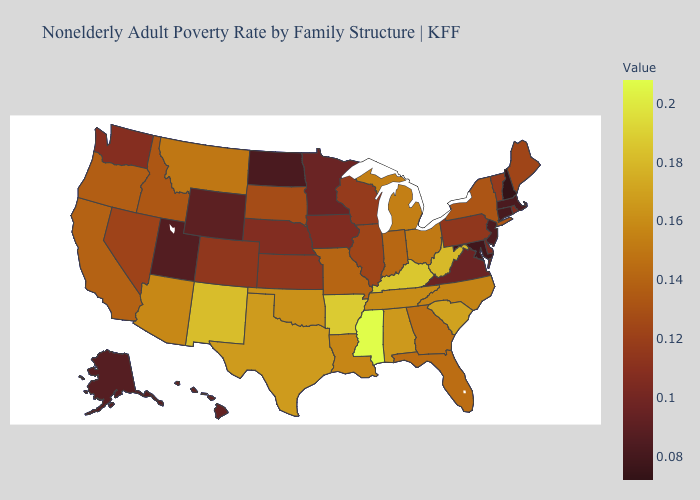Is the legend a continuous bar?
Concise answer only. Yes. Is the legend a continuous bar?
Quick response, please. Yes. 